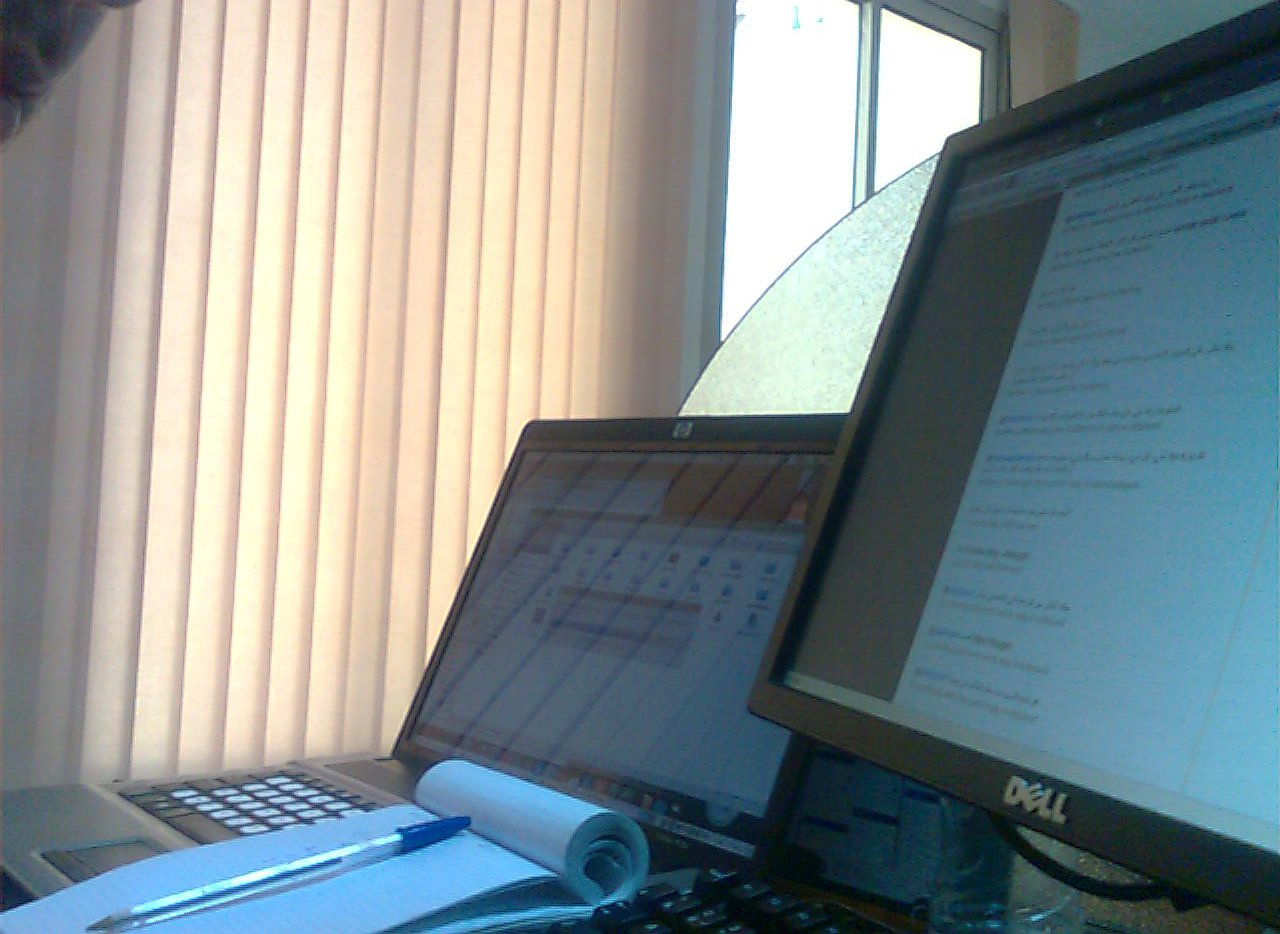What is the computer device? The computer device in question is a black-colored computer monitor, fundamental for display purposes in the setup. 